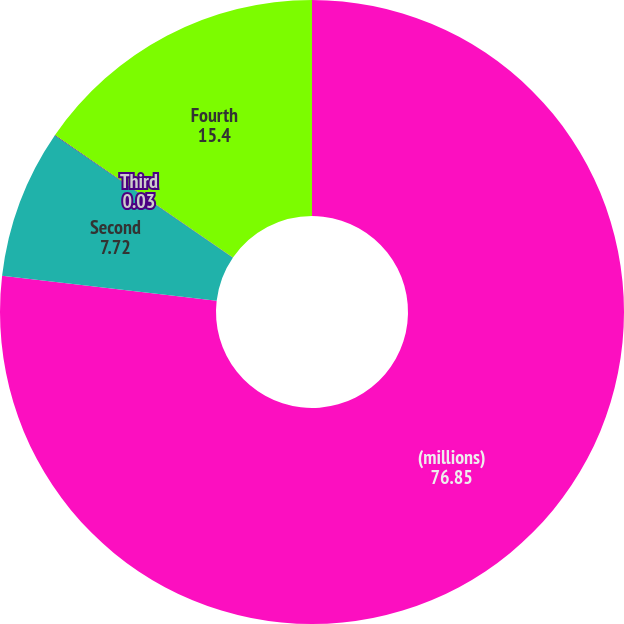<chart> <loc_0><loc_0><loc_500><loc_500><pie_chart><fcel>(millions)<fcel>Second<fcel>Third<fcel>Fourth<nl><fcel>76.85%<fcel>7.72%<fcel>0.03%<fcel>15.4%<nl></chart> 